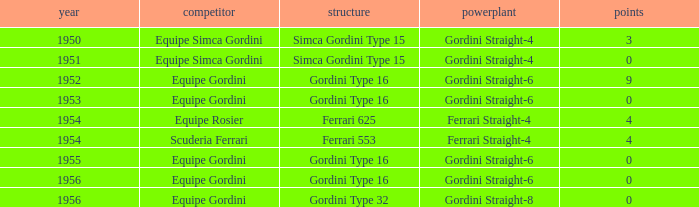Before 1956, what Chassis has Gordini Straight-4 engine with 3 points? Simca Gordini Type 15. 